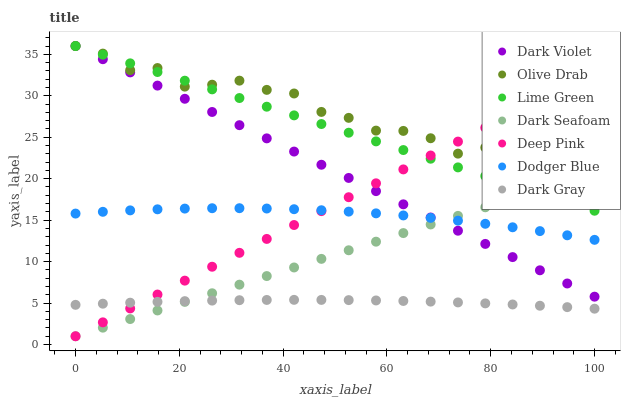Does Dark Gray have the minimum area under the curve?
Answer yes or no. Yes. Does Olive Drab have the maximum area under the curve?
Answer yes or no. Yes. Does Dark Violet have the minimum area under the curve?
Answer yes or no. No. Does Dark Violet have the maximum area under the curve?
Answer yes or no. No. Is Dark Seafoam the smoothest?
Answer yes or no. Yes. Is Olive Drab the roughest?
Answer yes or no. Yes. Is Dark Violet the smoothest?
Answer yes or no. No. Is Dark Violet the roughest?
Answer yes or no. No. Does Deep Pink have the lowest value?
Answer yes or no. Yes. Does Dark Violet have the lowest value?
Answer yes or no. No. Does Olive Drab have the highest value?
Answer yes or no. Yes. Does Dark Gray have the highest value?
Answer yes or no. No. Is Dark Gray less than Lime Green?
Answer yes or no. Yes. Is Olive Drab greater than Dodger Blue?
Answer yes or no. Yes. Does Deep Pink intersect Dark Seafoam?
Answer yes or no. Yes. Is Deep Pink less than Dark Seafoam?
Answer yes or no. No. Is Deep Pink greater than Dark Seafoam?
Answer yes or no. No. Does Dark Gray intersect Lime Green?
Answer yes or no. No. 